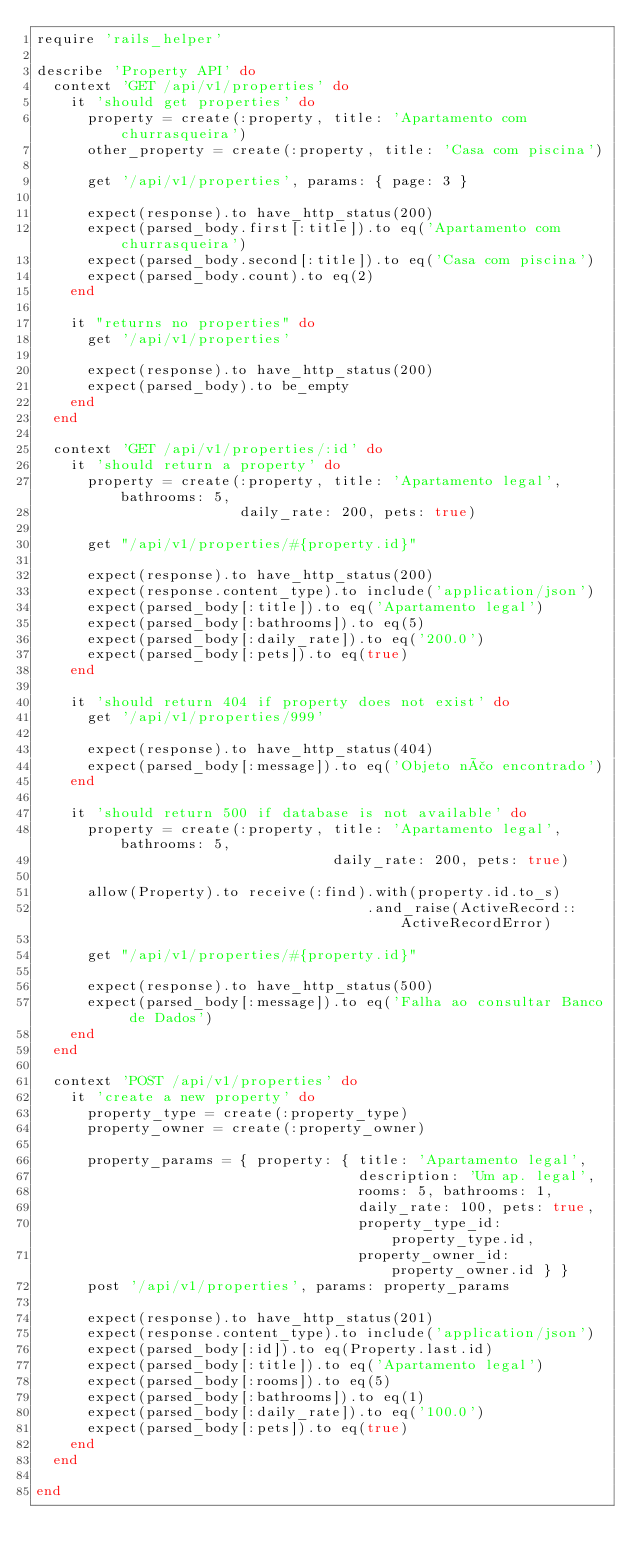<code> <loc_0><loc_0><loc_500><loc_500><_Ruby_>require 'rails_helper'

describe 'Property API' do
  context 'GET /api/v1/properties' do
    it 'should get properties' do
      property = create(:property, title: 'Apartamento com churrasqueira')
      other_property = create(:property, title: 'Casa com piscina')

      get '/api/v1/properties', params: { page: 3 }

      expect(response).to have_http_status(200)
      expect(parsed_body.first[:title]).to eq('Apartamento com churrasqueira')
      expect(parsed_body.second[:title]).to eq('Casa com piscina')
      expect(parsed_body.count).to eq(2)
    end

    it "returns no properties" do
      get '/api/v1/properties'

      expect(response).to have_http_status(200)
      expect(parsed_body).to be_empty
    end
  end

  context 'GET /api/v1/properties/:id' do
    it 'should return a property' do
      property = create(:property, title: 'Apartamento legal', bathrooms: 5,
                        daily_rate: 200, pets: true)

      get "/api/v1/properties/#{property.id}"

      expect(response).to have_http_status(200)
      expect(response.content_type).to include('application/json')
      expect(parsed_body[:title]).to eq('Apartamento legal')
      expect(parsed_body[:bathrooms]).to eq(5)
      expect(parsed_body[:daily_rate]).to eq('200.0')
      expect(parsed_body[:pets]).to eq(true)
    end

    it 'should return 404 if property does not exist' do
      get '/api/v1/properties/999'

      expect(response).to have_http_status(404)
      expect(parsed_body[:message]).to eq('Objeto não encontrado')
    end
    
    it 'should return 500 if database is not available' do
      property = create(:property, title: 'Apartamento legal', bathrooms: 5,
                                   daily_rate: 200, pets: true)

      allow(Property).to receive(:find).with(property.id.to_s)
                                       .and_raise(ActiveRecord::ActiveRecordError)

      get "/api/v1/properties/#{property.id}"

      expect(response).to have_http_status(500)
      expect(parsed_body[:message]).to eq('Falha ao consultar Banco de Dados')
    end
  end

  context 'POST /api/v1/properties' do
    it 'create a new property' do
      property_type = create(:property_type)
      property_owner = create(:property_owner)      

      property_params = { property: { title: 'Apartamento legal',
                                      description: 'Um ap. legal',
                                      rooms: 5, bathrooms: 1,
                                      daily_rate: 100, pets: true,
                                      property_type_id: property_type.id,
                                      property_owner_id: property_owner.id } }
      post '/api/v1/properties', params: property_params

      expect(response).to have_http_status(201) 
      expect(response.content_type).to include('application/json')
      expect(parsed_body[:id]).to eq(Property.last.id)
      expect(parsed_body[:title]).to eq('Apartamento legal')
      expect(parsed_body[:rooms]).to eq(5)
      expect(parsed_body[:bathrooms]).to eq(1)
      expect(parsed_body[:daily_rate]).to eq('100.0')
      expect(parsed_body[:pets]).to eq(true)
    end
  end
  
end
</code> 